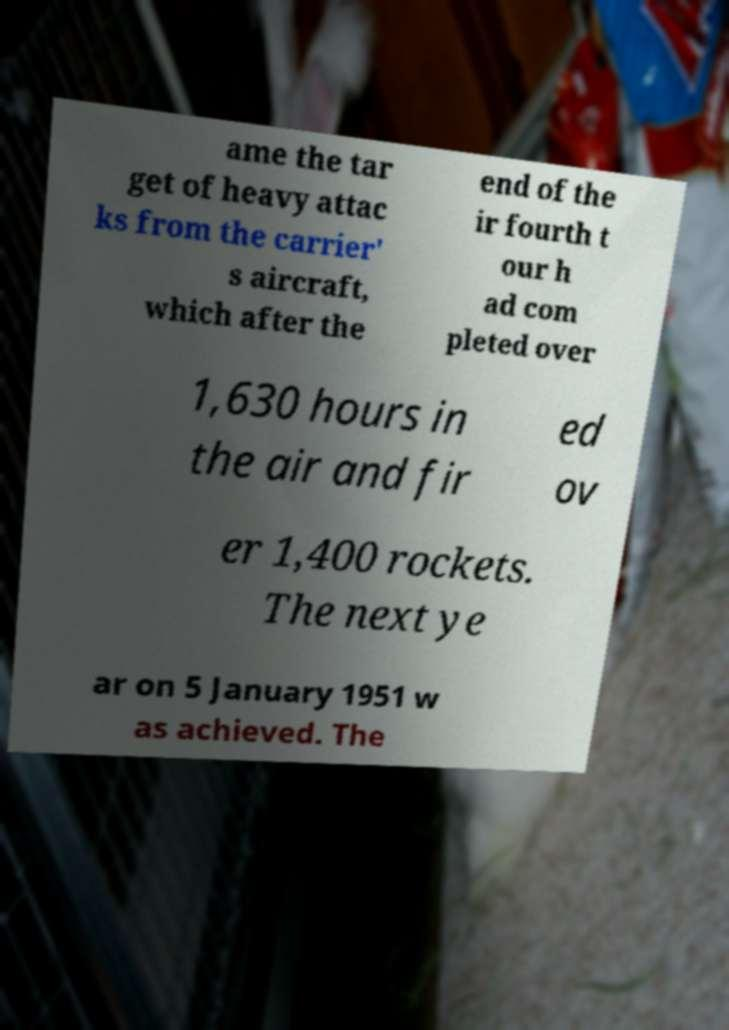I need the written content from this picture converted into text. Can you do that? ame the tar get of heavy attac ks from the carrier' s aircraft, which after the end of the ir fourth t our h ad com pleted over 1,630 hours in the air and fir ed ov er 1,400 rockets. The next ye ar on 5 January 1951 w as achieved. The 